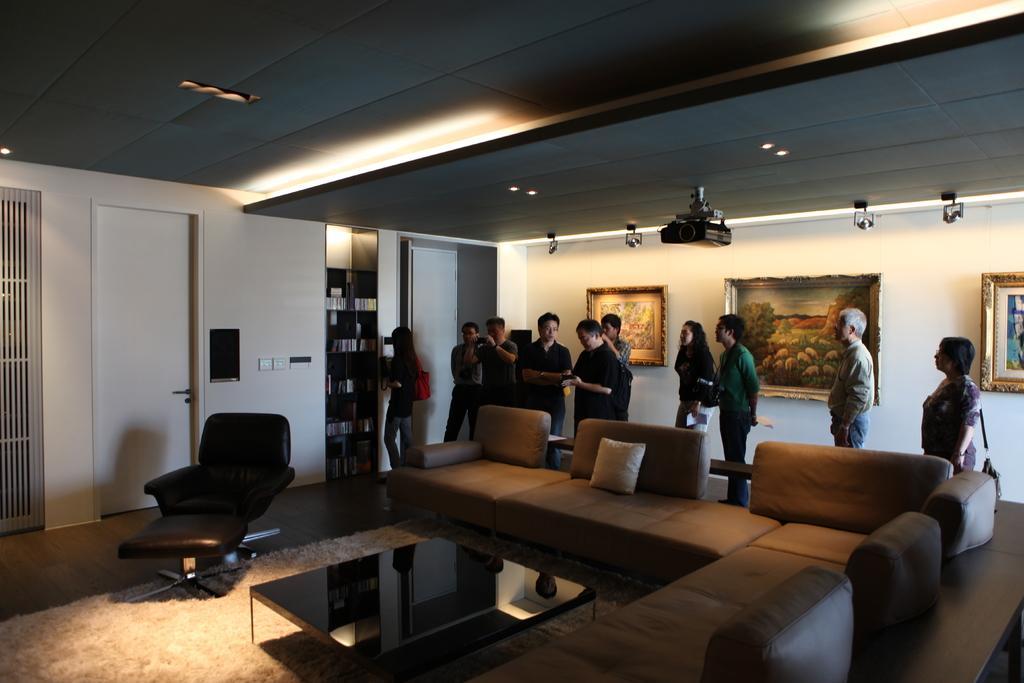Describe this image in one or two sentences. The image is taken in the room. In the center of the room there are sofas, table and a chair. On the right there are people standing. We can see photo frames which are placed on the wall. On the left there is a door, wall and shelves. At the top there are lights. 